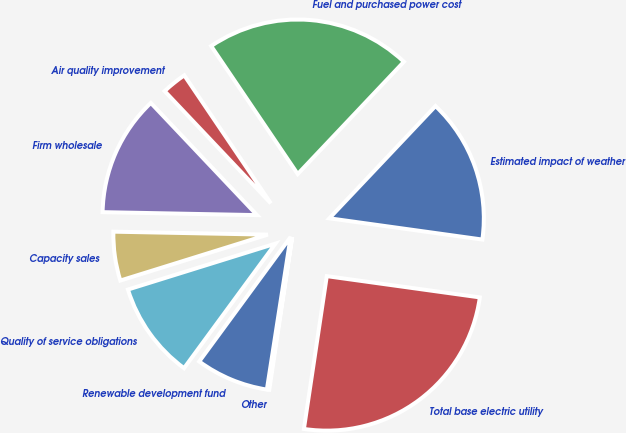Convert chart. <chart><loc_0><loc_0><loc_500><loc_500><pie_chart><fcel>Estimated impact of weather<fcel>Fuel and purchased power cost<fcel>Air quality improvement<fcel>Firm wholesale<fcel>Capacity sales<fcel>Quality of service obligations<fcel>Renewable development fund<fcel>Other<fcel>Total base electric utility<nl><fcel>15.14%<fcel>21.52%<fcel>2.6%<fcel>12.63%<fcel>5.11%<fcel>10.12%<fcel>7.62%<fcel>0.09%<fcel>25.17%<nl></chart> 